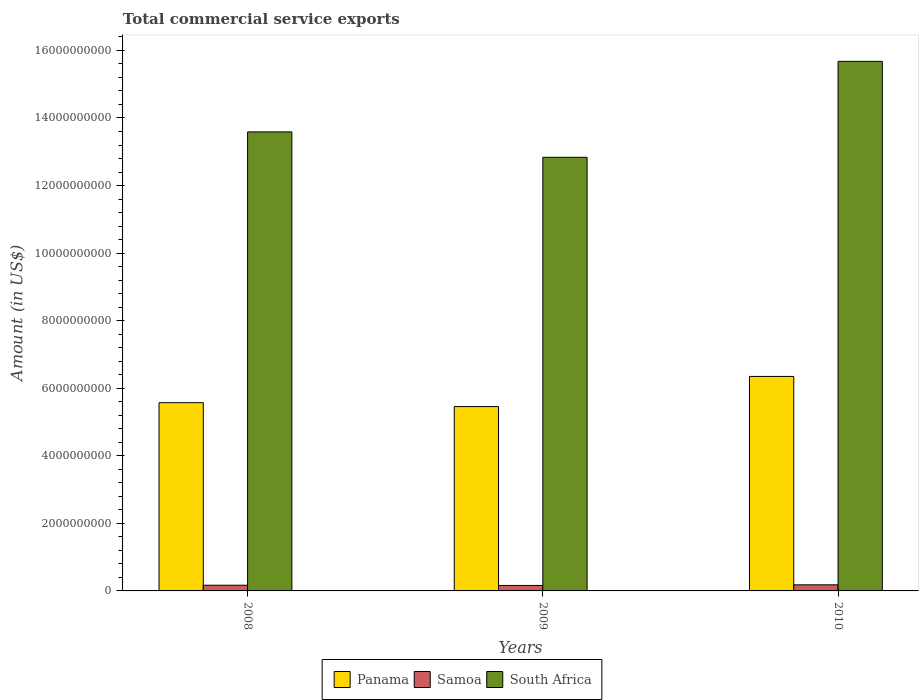How many groups of bars are there?
Make the answer very short. 3. How many bars are there on the 3rd tick from the left?
Make the answer very short. 3. How many bars are there on the 1st tick from the right?
Offer a very short reply. 3. In how many cases, is the number of bars for a given year not equal to the number of legend labels?
Provide a succinct answer. 0. What is the total commercial service exports in South Africa in 2009?
Ensure brevity in your answer.  1.28e+1. Across all years, what is the maximum total commercial service exports in South Africa?
Offer a very short reply. 1.57e+1. Across all years, what is the minimum total commercial service exports in Samoa?
Offer a terse response. 1.62e+08. In which year was the total commercial service exports in South Africa maximum?
Offer a very short reply. 2010. In which year was the total commercial service exports in South Africa minimum?
Offer a terse response. 2009. What is the total total commercial service exports in South Africa in the graph?
Give a very brief answer. 4.21e+1. What is the difference between the total commercial service exports in Panama in 2008 and that in 2009?
Your answer should be compact. 1.16e+08. What is the difference between the total commercial service exports in South Africa in 2008 and the total commercial service exports in Panama in 2010?
Your response must be concise. 7.24e+09. What is the average total commercial service exports in Samoa per year?
Your answer should be very brief. 1.70e+08. In the year 2009, what is the difference between the total commercial service exports in Samoa and total commercial service exports in South Africa?
Make the answer very short. -1.27e+1. What is the ratio of the total commercial service exports in Samoa in 2008 to that in 2009?
Provide a succinct answer. 1.04. Is the total commercial service exports in Samoa in 2008 less than that in 2009?
Provide a short and direct response. No. Is the difference between the total commercial service exports in Samoa in 2008 and 2009 greater than the difference between the total commercial service exports in South Africa in 2008 and 2009?
Offer a very short reply. No. What is the difference between the highest and the second highest total commercial service exports in Samoa?
Provide a short and direct response. 1.21e+07. What is the difference between the highest and the lowest total commercial service exports in South Africa?
Your answer should be very brief. 2.84e+09. Is the sum of the total commercial service exports in Panama in 2009 and 2010 greater than the maximum total commercial service exports in Samoa across all years?
Provide a short and direct response. Yes. What does the 2nd bar from the left in 2009 represents?
Your response must be concise. Samoa. What does the 2nd bar from the right in 2008 represents?
Provide a short and direct response. Samoa. Is it the case that in every year, the sum of the total commercial service exports in Panama and total commercial service exports in South Africa is greater than the total commercial service exports in Samoa?
Ensure brevity in your answer.  Yes. Are all the bars in the graph horizontal?
Offer a terse response. No. Are the values on the major ticks of Y-axis written in scientific E-notation?
Ensure brevity in your answer.  No. Does the graph contain any zero values?
Keep it short and to the point. No. Does the graph contain grids?
Your response must be concise. No. Where does the legend appear in the graph?
Your answer should be compact. Bottom center. How many legend labels are there?
Ensure brevity in your answer.  3. How are the legend labels stacked?
Your answer should be compact. Horizontal. What is the title of the graph?
Offer a very short reply. Total commercial service exports. Does "Venezuela" appear as one of the legend labels in the graph?
Provide a short and direct response. No. What is the label or title of the Y-axis?
Give a very brief answer. Amount (in US$). What is the Amount (in US$) of Panama in 2008?
Give a very brief answer. 5.57e+09. What is the Amount (in US$) in Samoa in 2008?
Make the answer very short. 1.68e+08. What is the Amount (in US$) of South Africa in 2008?
Offer a terse response. 1.36e+1. What is the Amount (in US$) in Panama in 2009?
Your answer should be compact. 5.46e+09. What is the Amount (in US$) of Samoa in 2009?
Provide a short and direct response. 1.62e+08. What is the Amount (in US$) in South Africa in 2009?
Your answer should be compact. 1.28e+1. What is the Amount (in US$) of Panama in 2010?
Your answer should be very brief. 6.35e+09. What is the Amount (in US$) in Samoa in 2010?
Your answer should be compact. 1.80e+08. What is the Amount (in US$) of South Africa in 2010?
Keep it short and to the point. 1.57e+1. Across all years, what is the maximum Amount (in US$) of Panama?
Your response must be concise. 6.35e+09. Across all years, what is the maximum Amount (in US$) of Samoa?
Your answer should be very brief. 1.80e+08. Across all years, what is the maximum Amount (in US$) of South Africa?
Provide a short and direct response. 1.57e+1. Across all years, what is the minimum Amount (in US$) of Panama?
Ensure brevity in your answer.  5.46e+09. Across all years, what is the minimum Amount (in US$) of Samoa?
Provide a succinct answer. 1.62e+08. Across all years, what is the minimum Amount (in US$) in South Africa?
Give a very brief answer. 1.28e+1. What is the total Amount (in US$) of Panama in the graph?
Give a very brief answer. 1.74e+1. What is the total Amount (in US$) in Samoa in the graph?
Keep it short and to the point. 5.11e+08. What is the total Amount (in US$) in South Africa in the graph?
Offer a very short reply. 4.21e+1. What is the difference between the Amount (in US$) of Panama in 2008 and that in 2009?
Your answer should be compact. 1.16e+08. What is the difference between the Amount (in US$) in Samoa in 2008 and that in 2009?
Your answer should be very brief. 6.30e+06. What is the difference between the Amount (in US$) in South Africa in 2008 and that in 2009?
Provide a succinct answer. 7.52e+08. What is the difference between the Amount (in US$) in Panama in 2008 and that in 2010?
Provide a succinct answer. -7.77e+08. What is the difference between the Amount (in US$) of Samoa in 2008 and that in 2010?
Provide a short and direct response. -1.21e+07. What is the difference between the Amount (in US$) of South Africa in 2008 and that in 2010?
Offer a very short reply. -2.09e+09. What is the difference between the Amount (in US$) in Panama in 2009 and that in 2010?
Your response must be concise. -8.93e+08. What is the difference between the Amount (in US$) in Samoa in 2009 and that in 2010?
Keep it short and to the point. -1.84e+07. What is the difference between the Amount (in US$) of South Africa in 2009 and that in 2010?
Offer a very short reply. -2.84e+09. What is the difference between the Amount (in US$) in Panama in 2008 and the Amount (in US$) in Samoa in 2009?
Offer a terse response. 5.41e+09. What is the difference between the Amount (in US$) of Panama in 2008 and the Amount (in US$) of South Africa in 2009?
Give a very brief answer. -7.26e+09. What is the difference between the Amount (in US$) in Samoa in 2008 and the Amount (in US$) in South Africa in 2009?
Offer a very short reply. -1.27e+1. What is the difference between the Amount (in US$) of Panama in 2008 and the Amount (in US$) of Samoa in 2010?
Offer a terse response. 5.39e+09. What is the difference between the Amount (in US$) in Panama in 2008 and the Amount (in US$) in South Africa in 2010?
Your response must be concise. -1.01e+1. What is the difference between the Amount (in US$) of Samoa in 2008 and the Amount (in US$) of South Africa in 2010?
Your response must be concise. -1.55e+1. What is the difference between the Amount (in US$) in Panama in 2009 and the Amount (in US$) in Samoa in 2010?
Your answer should be compact. 5.28e+09. What is the difference between the Amount (in US$) in Panama in 2009 and the Amount (in US$) in South Africa in 2010?
Provide a succinct answer. -1.02e+1. What is the difference between the Amount (in US$) of Samoa in 2009 and the Amount (in US$) of South Africa in 2010?
Give a very brief answer. -1.55e+1. What is the average Amount (in US$) of Panama per year?
Your response must be concise. 5.79e+09. What is the average Amount (in US$) of Samoa per year?
Your answer should be compact. 1.70e+08. What is the average Amount (in US$) in South Africa per year?
Keep it short and to the point. 1.40e+1. In the year 2008, what is the difference between the Amount (in US$) of Panama and Amount (in US$) of Samoa?
Offer a terse response. 5.40e+09. In the year 2008, what is the difference between the Amount (in US$) in Panama and Amount (in US$) in South Africa?
Provide a succinct answer. -8.02e+09. In the year 2008, what is the difference between the Amount (in US$) of Samoa and Amount (in US$) of South Africa?
Offer a terse response. -1.34e+1. In the year 2009, what is the difference between the Amount (in US$) in Panama and Amount (in US$) in Samoa?
Keep it short and to the point. 5.29e+09. In the year 2009, what is the difference between the Amount (in US$) in Panama and Amount (in US$) in South Africa?
Keep it short and to the point. -7.38e+09. In the year 2009, what is the difference between the Amount (in US$) in Samoa and Amount (in US$) in South Africa?
Ensure brevity in your answer.  -1.27e+1. In the year 2010, what is the difference between the Amount (in US$) of Panama and Amount (in US$) of Samoa?
Your answer should be compact. 6.17e+09. In the year 2010, what is the difference between the Amount (in US$) in Panama and Amount (in US$) in South Africa?
Ensure brevity in your answer.  -9.33e+09. In the year 2010, what is the difference between the Amount (in US$) of Samoa and Amount (in US$) of South Africa?
Offer a terse response. -1.55e+1. What is the ratio of the Amount (in US$) in Panama in 2008 to that in 2009?
Your answer should be very brief. 1.02. What is the ratio of the Amount (in US$) of Samoa in 2008 to that in 2009?
Offer a terse response. 1.04. What is the ratio of the Amount (in US$) of South Africa in 2008 to that in 2009?
Make the answer very short. 1.06. What is the ratio of the Amount (in US$) of Panama in 2008 to that in 2010?
Make the answer very short. 0.88. What is the ratio of the Amount (in US$) in Samoa in 2008 to that in 2010?
Your response must be concise. 0.93. What is the ratio of the Amount (in US$) in South Africa in 2008 to that in 2010?
Keep it short and to the point. 0.87. What is the ratio of the Amount (in US$) of Panama in 2009 to that in 2010?
Give a very brief answer. 0.86. What is the ratio of the Amount (in US$) in Samoa in 2009 to that in 2010?
Your answer should be very brief. 0.9. What is the ratio of the Amount (in US$) of South Africa in 2009 to that in 2010?
Provide a short and direct response. 0.82. What is the difference between the highest and the second highest Amount (in US$) of Panama?
Offer a very short reply. 7.77e+08. What is the difference between the highest and the second highest Amount (in US$) of Samoa?
Make the answer very short. 1.21e+07. What is the difference between the highest and the second highest Amount (in US$) in South Africa?
Offer a very short reply. 2.09e+09. What is the difference between the highest and the lowest Amount (in US$) in Panama?
Your response must be concise. 8.93e+08. What is the difference between the highest and the lowest Amount (in US$) of Samoa?
Give a very brief answer. 1.84e+07. What is the difference between the highest and the lowest Amount (in US$) of South Africa?
Ensure brevity in your answer.  2.84e+09. 